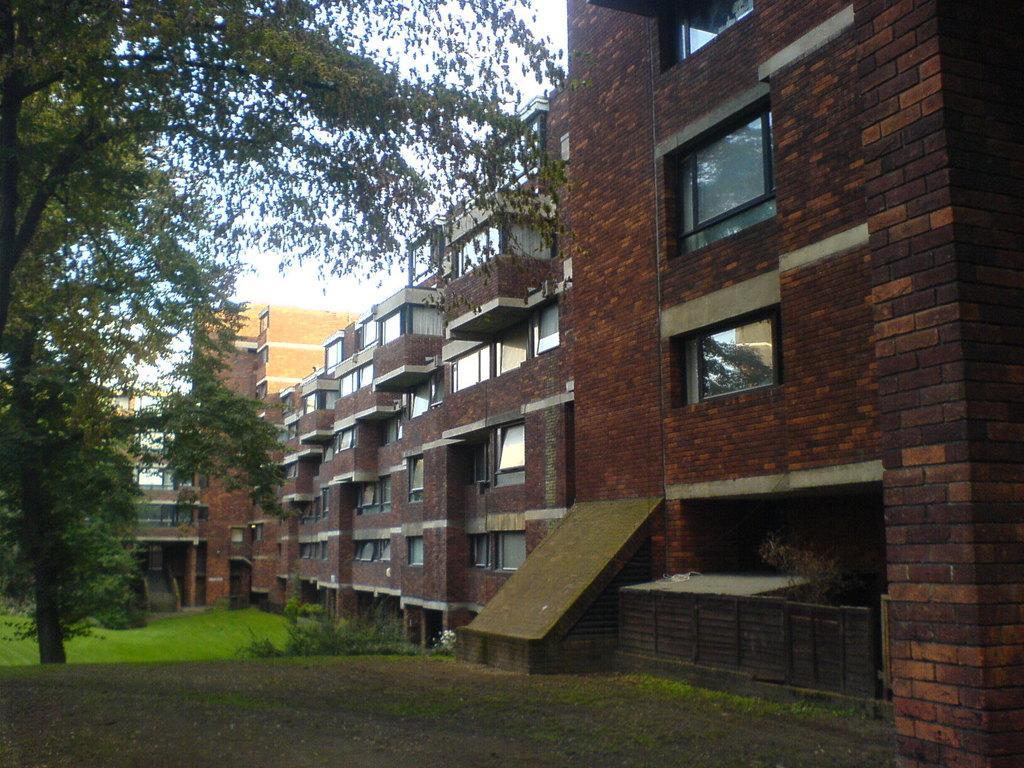Please provide a concise description of this image. In this image there are buildings, in front of the building there is grass on the surface and there is a tree. 